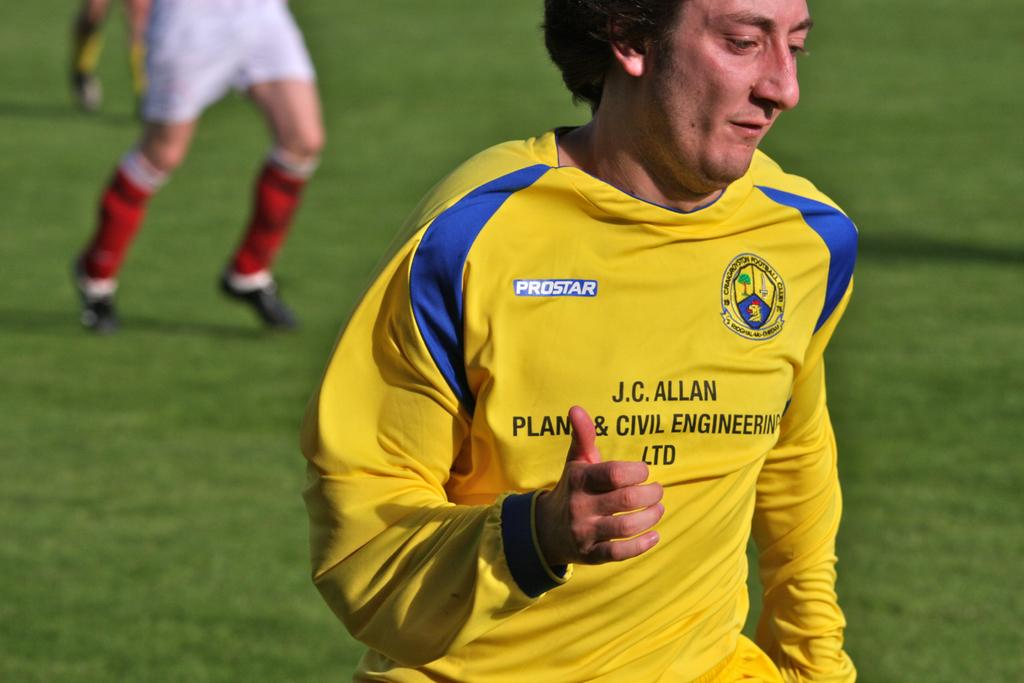<image>
Share a concise interpretation of the image provided. the soccer player j c allan is doing a thumbs up motion at the camera. 